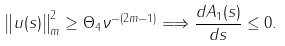<formula> <loc_0><loc_0><loc_500><loc_500>& \left \| u ( s ) \right \| ^ { 2 } _ { m } \geq \Theta _ { 4 } \nu ^ { - ( 2 m - 1 ) } \Longrightarrow \frac { d A _ { 1 } ( s ) } { d s } \leq 0 .</formula> 